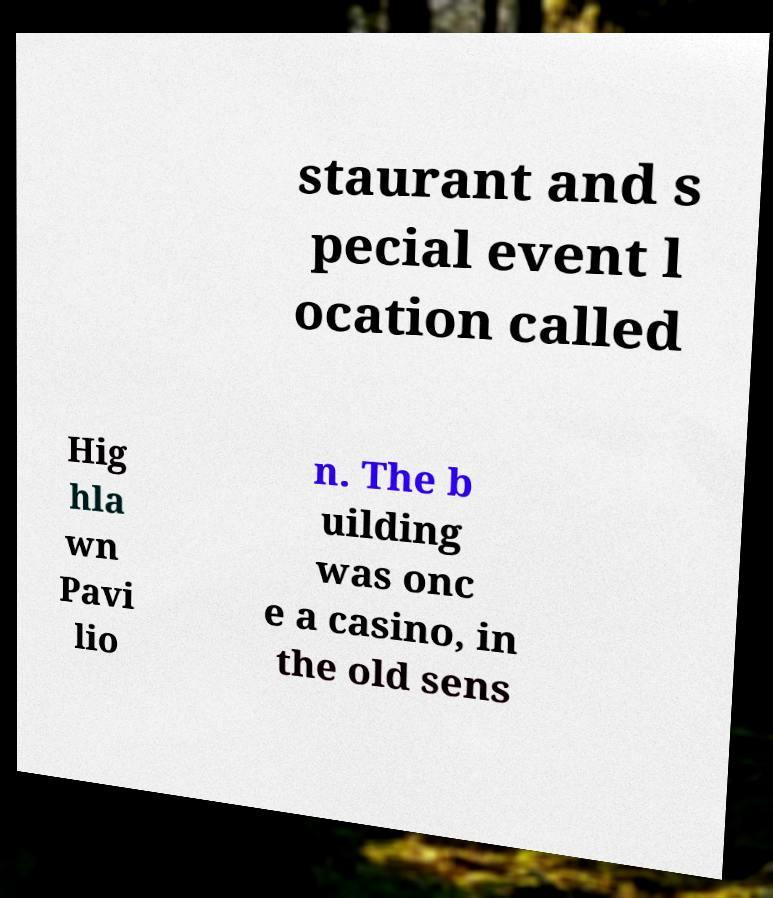Could you extract and type out the text from this image? staurant and s pecial event l ocation called Hig hla wn Pavi lio n. The b uilding was onc e a casino, in the old sens 